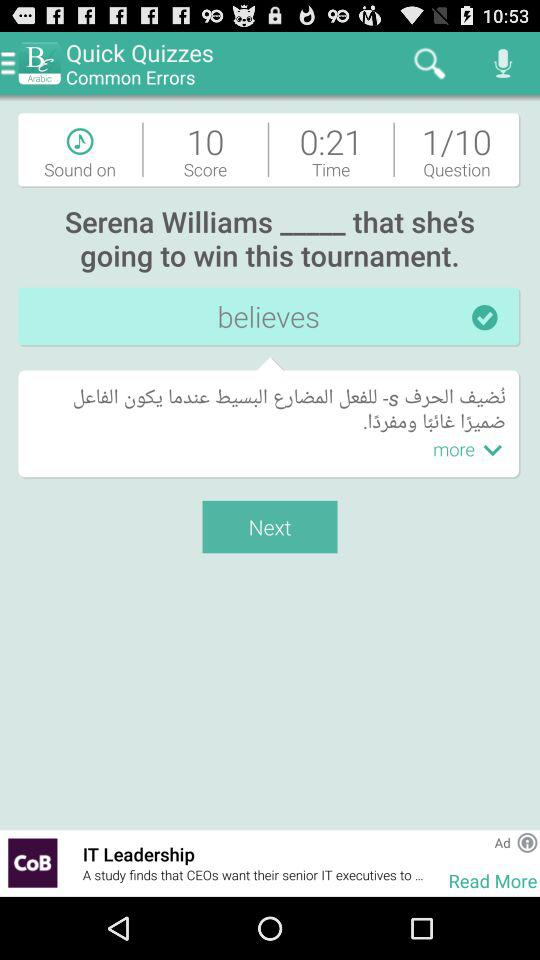How long did you spend on the quiz? You spent 21 seconds on the quiz. 